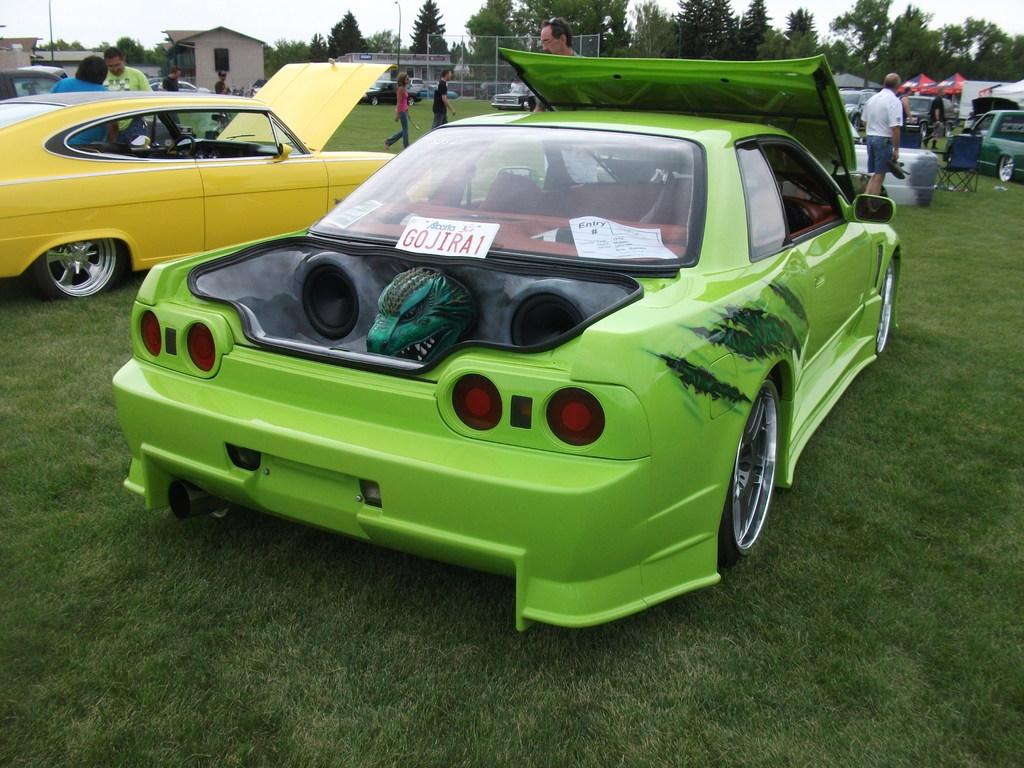What is the licence plate number on the green car?
Your response must be concise. Gojira1. 